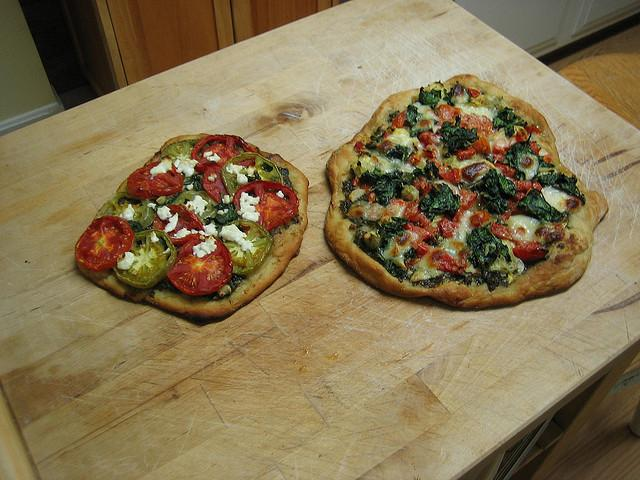What are the green vegetables next to the red tomatoes on the left-side pizza? Please explain your reasoning. green tomatoes. They are green but in the same shape and size as the red ones. 